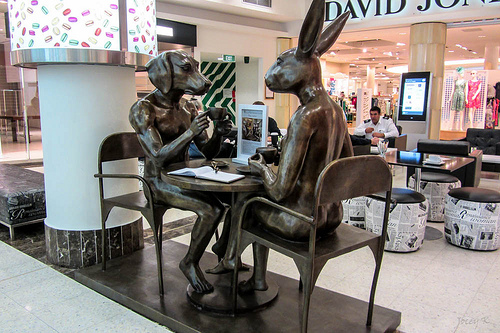<image>
Can you confirm if the statue is in front of the statue? Yes. The statue is positioned in front of the statue, appearing closer to the camera viewpoint. 